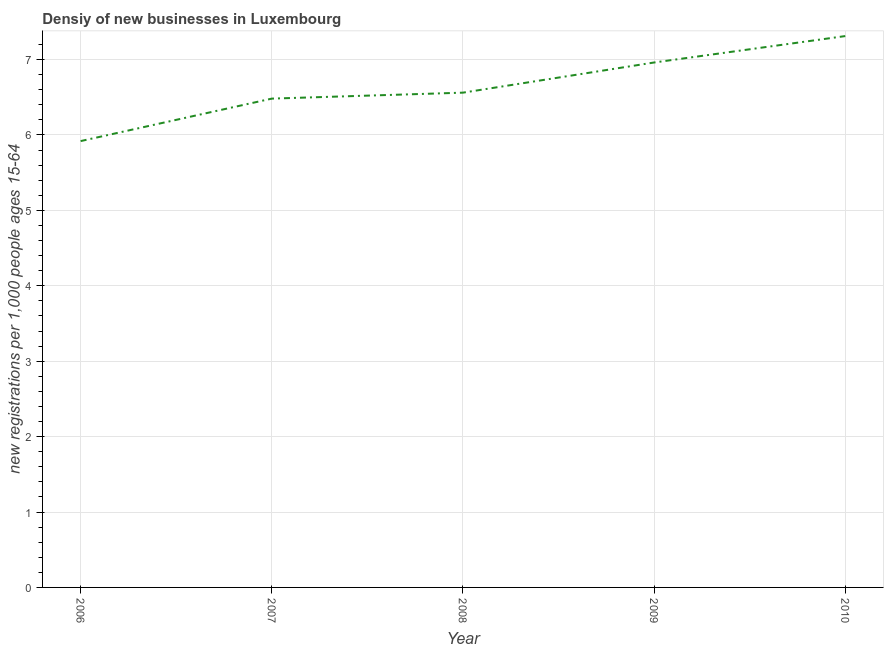What is the density of new business in 2009?
Ensure brevity in your answer.  6.96. Across all years, what is the maximum density of new business?
Provide a succinct answer. 7.31. Across all years, what is the minimum density of new business?
Your answer should be very brief. 5.92. In which year was the density of new business minimum?
Your answer should be very brief. 2006. What is the sum of the density of new business?
Your answer should be compact. 33.24. What is the difference between the density of new business in 2006 and 2009?
Make the answer very short. -1.04. What is the average density of new business per year?
Your answer should be very brief. 6.65. What is the median density of new business?
Your answer should be very brief. 6.56. In how many years, is the density of new business greater than 4 ?
Keep it short and to the point. 5. Do a majority of the years between 2009 and 2007 (inclusive) have density of new business greater than 1 ?
Make the answer very short. No. What is the ratio of the density of new business in 2006 to that in 2010?
Provide a succinct answer. 0.81. Is the density of new business in 2006 less than that in 2007?
Ensure brevity in your answer.  Yes. Is the difference between the density of new business in 2006 and 2008 greater than the difference between any two years?
Offer a terse response. No. What is the difference between the highest and the second highest density of new business?
Give a very brief answer. 0.35. Is the sum of the density of new business in 2006 and 2009 greater than the maximum density of new business across all years?
Provide a succinct answer. Yes. What is the difference between the highest and the lowest density of new business?
Your response must be concise. 1.39. In how many years, is the density of new business greater than the average density of new business taken over all years?
Your answer should be very brief. 2. Does the density of new business monotonically increase over the years?
Your answer should be very brief. Yes. How many years are there in the graph?
Keep it short and to the point. 5. What is the title of the graph?
Ensure brevity in your answer.  Densiy of new businesses in Luxembourg. What is the label or title of the Y-axis?
Your answer should be compact. New registrations per 1,0 people ages 15-64. What is the new registrations per 1,000 people ages 15-64 of 2006?
Offer a terse response. 5.92. What is the new registrations per 1,000 people ages 15-64 of 2007?
Your response must be concise. 6.48. What is the new registrations per 1,000 people ages 15-64 of 2008?
Offer a terse response. 6.56. What is the new registrations per 1,000 people ages 15-64 in 2009?
Provide a short and direct response. 6.96. What is the new registrations per 1,000 people ages 15-64 in 2010?
Give a very brief answer. 7.31. What is the difference between the new registrations per 1,000 people ages 15-64 in 2006 and 2007?
Make the answer very short. -0.56. What is the difference between the new registrations per 1,000 people ages 15-64 in 2006 and 2008?
Make the answer very short. -0.64. What is the difference between the new registrations per 1,000 people ages 15-64 in 2006 and 2009?
Ensure brevity in your answer.  -1.04. What is the difference between the new registrations per 1,000 people ages 15-64 in 2006 and 2010?
Your answer should be very brief. -1.39. What is the difference between the new registrations per 1,000 people ages 15-64 in 2007 and 2008?
Offer a terse response. -0.08. What is the difference between the new registrations per 1,000 people ages 15-64 in 2007 and 2009?
Your answer should be very brief. -0.48. What is the difference between the new registrations per 1,000 people ages 15-64 in 2007 and 2010?
Give a very brief answer. -0.83. What is the difference between the new registrations per 1,000 people ages 15-64 in 2008 and 2009?
Ensure brevity in your answer.  -0.4. What is the difference between the new registrations per 1,000 people ages 15-64 in 2008 and 2010?
Ensure brevity in your answer.  -0.75. What is the difference between the new registrations per 1,000 people ages 15-64 in 2009 and 2010?
Ensure brevity in your answer.  -0.35. What is the ratio of the new registrations per 1,000 people ages 15-64 in 2006 to that in 2007?
Give a very brief answer. 0.91. What is the ratio of the new registrations per 1,000 people ages 15-64 in 2006 to that in 2008?
Ensure brevity in your answer.  0.9. What is the ratio of the new registrations per 1,000 people ages 15-64 in 2006 to that in 2010?
Ensure brevity in your answer.  0.81. What is the ratio of the new registrations per 1,000 people ages 15-64 in 2007 to that in 2010?
Your answer should be compact. 0.89. What is the ratio of the new registrations per 1,000 people ages 15-64 in 2008 to that in 2009?
Offer a terse response. 0.94. What is the ratio of the new registrations per 1,000 people ages 15-64 in 2008 to that in 2010?
Keep it short and to the point. 0.9. What is the ratio of the new registrations per 1,000 people ages 15-64 in 2009 to that in 2010?
Provide a succinct answer. 0.95. 